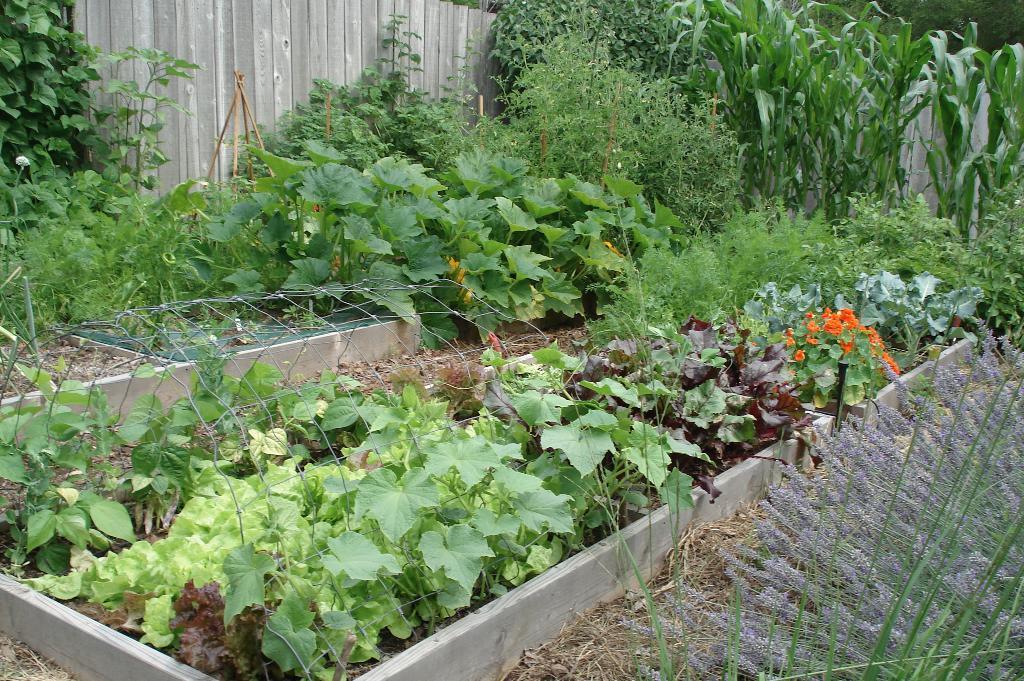In one or two sentences, can you explain what this image depicts? In this image we can see plants and creepers. Also there is a concrete box with mesh. In the back there is a wooden fencing. 